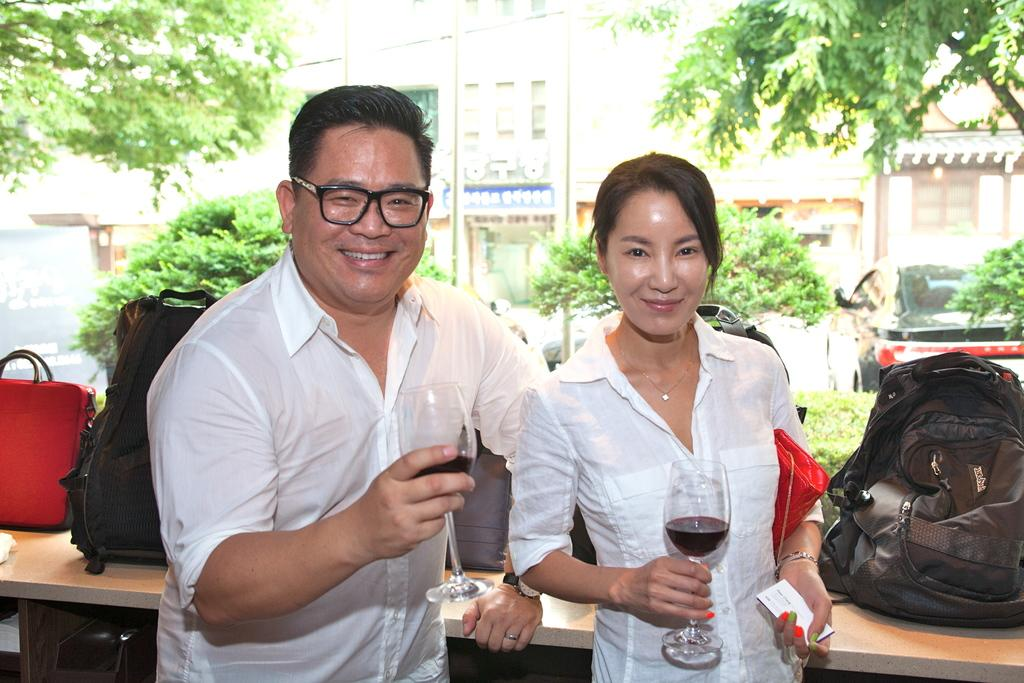How many people are in the image? There are two people in the image. Can you describe the individuals in the image? One person is a man standing on the left, and the other person is a woman standing on the right. What are the people holding in the image? Both the man and the woman are holding a glass. What type of care can be seen being provided to the bushes in the image? There are no bushes present in the image, so no care is being provided to them. 